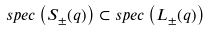<formula> <loc_0><loc_0><loc_500><loc_500>s p e c \left ( S _ { \pm } ( q ) \right ) \subset s p e c \left ( L _ { \pm } ( q ) \right )</formula> 